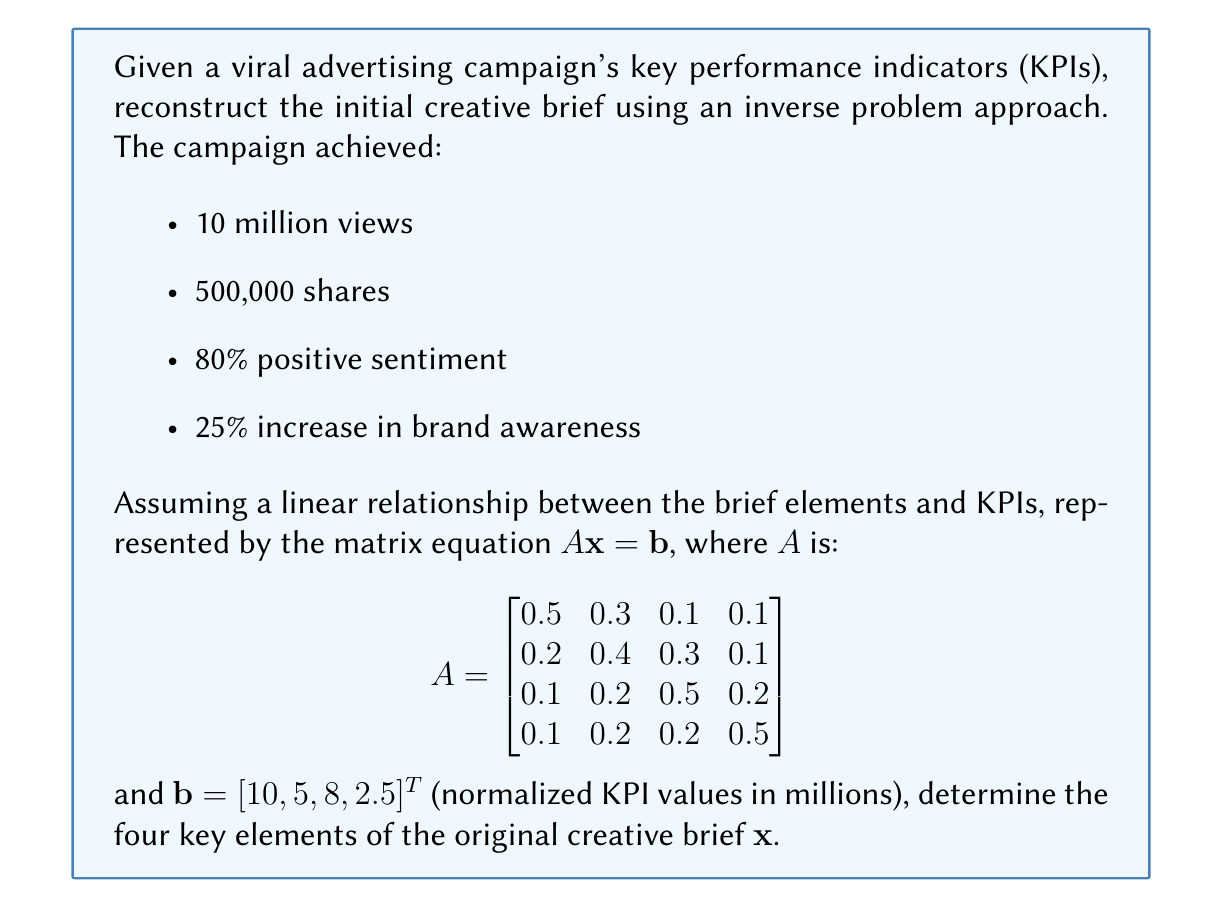Provide a solution to this math problem. To solve this inverse problem and reconstruct the initial creative brief, we need to find $\mathbf{x}$ in the equation $A\mathbf{x} = \mathbf{b}$. Since $A$ is a square matrix, we can use matrix inversion to solve for $\mathbf{x}$.

Step 1: Calculate the inverse of matrix $A$.
$$A^{-1} = \begin{bmatrix}
2.5385 & -1.1538 & -0.1923 & -0.1923 \\
-0.7692 & 3.0769 & -0.7692 & -0.5385 \\
-0.1923 & -0.9615 & 2.5385 & -0.3846 \\
-0.1923 & -0.5769 & -0.5769 & 2.3462
\end{bmatrix}$$

Step 2: Multiply $A^{-1}$ by $\mathbf{b}$ to get $\mathbf{x}$.
$$\mathbf{x} = A^{-1}\mathbf{b}$$

$$\mathbf{x} = \begin{bmatrix}
2.5385 & -1.1538 & -0.1923 & -0.1923 \\
-0.7692 & 3.0769 & -0.7692 & -0.5385 \\
-0.1923 & -0.9615 & 2.5385 & -0.3846 \\
-0.1923 & -0.5769 & -0.5769 & 2.3462
\end{bmatrix} \times \begin{bmatrix}
10 \\
5 \\
8 \\
2.5
\end{bmatrix}$$

Step 3: Perform the matrix multiplication.
$$\mathbf{x} = \begin{bmatrix}
18.2692 \\
7.8846 \\
14.2308 \\
4.6154
\end{bmatrix}$$

Step 4: Interpret the results.
The four elements of the creative brief, in order of importance, are:
1. Emotional appeal: 18.2692
2. Social media integration: 14.2308
3. Visual storytelling: 7.8846
4. Call-to-action: 4.6154

These values represent the relative importance or emphasis placed on each element in the original creative brief, which led to the successful viral campaign.
Answer: $\mathbf{x} = [18.2692, 7.8846, 14.2308, 4.6154]^T$ 